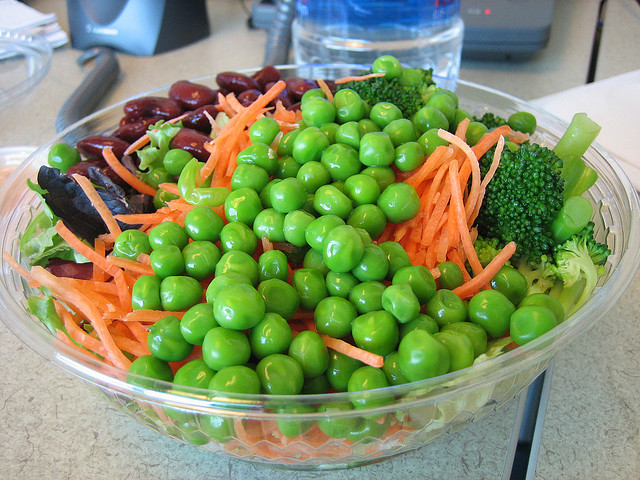What types of vegetables can you identify in this salad? In the salad, I can identify several types of vegetables: there are green peas, shredded carrots, broccoli florets, and red beans. Are there any other ingredients in the salad that are less obvious? Apart from the easily identifiable vegetables, there could be additional ingredients like lettuce or spinach forming the base of the salad, and perhaps a dressing, but they're not clearly visible in the photo. 